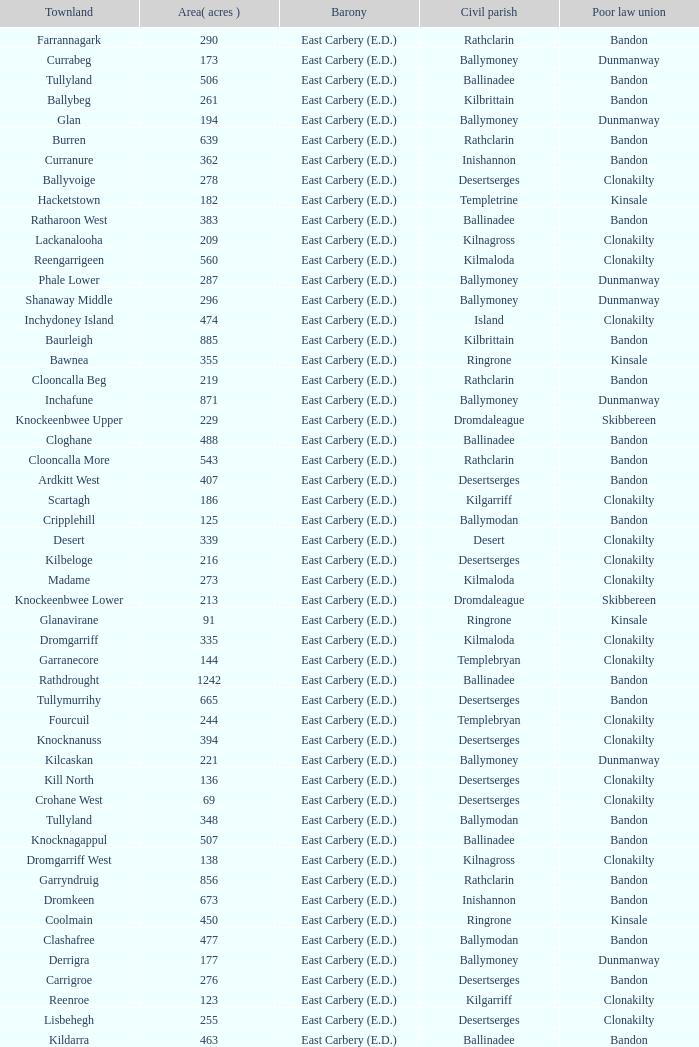What is the poor law union of the Ardacrow townland? Bandon. 